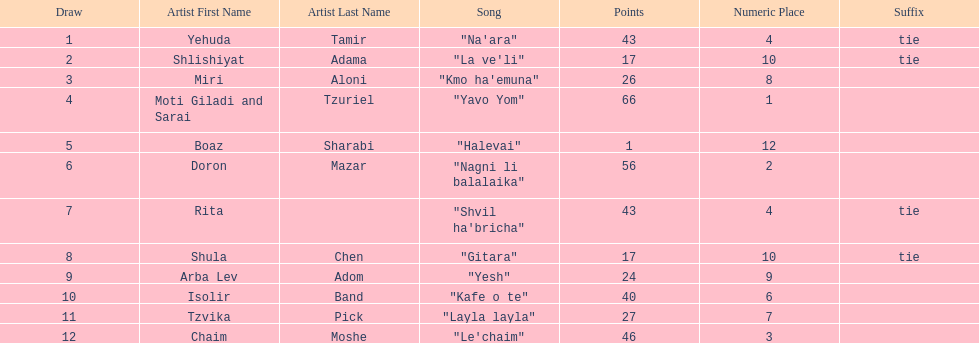What is the name of the first song listed on this chart? "Na'ara". 